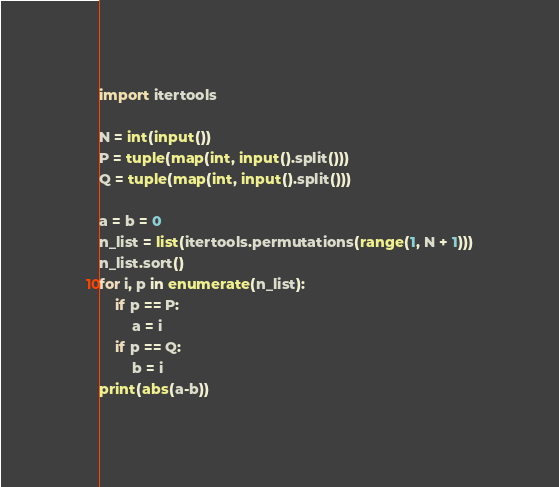Convert code to text. <code><loc_0><loc_0><loc_500><loc_500><_Python_>import itertools

N = int(input())
P = tuple(map(int, input().split()))
Q = tuple(map(int, input().split()))

a = b = 0
n_list = list(itertools.permutations(range(1, N + 1)))
n_list.sort()
for i, p in enumerate(n_list):
	if p == P:
		a = i
	if p == Q:
		b = i
print(abs(a-b))</code> 